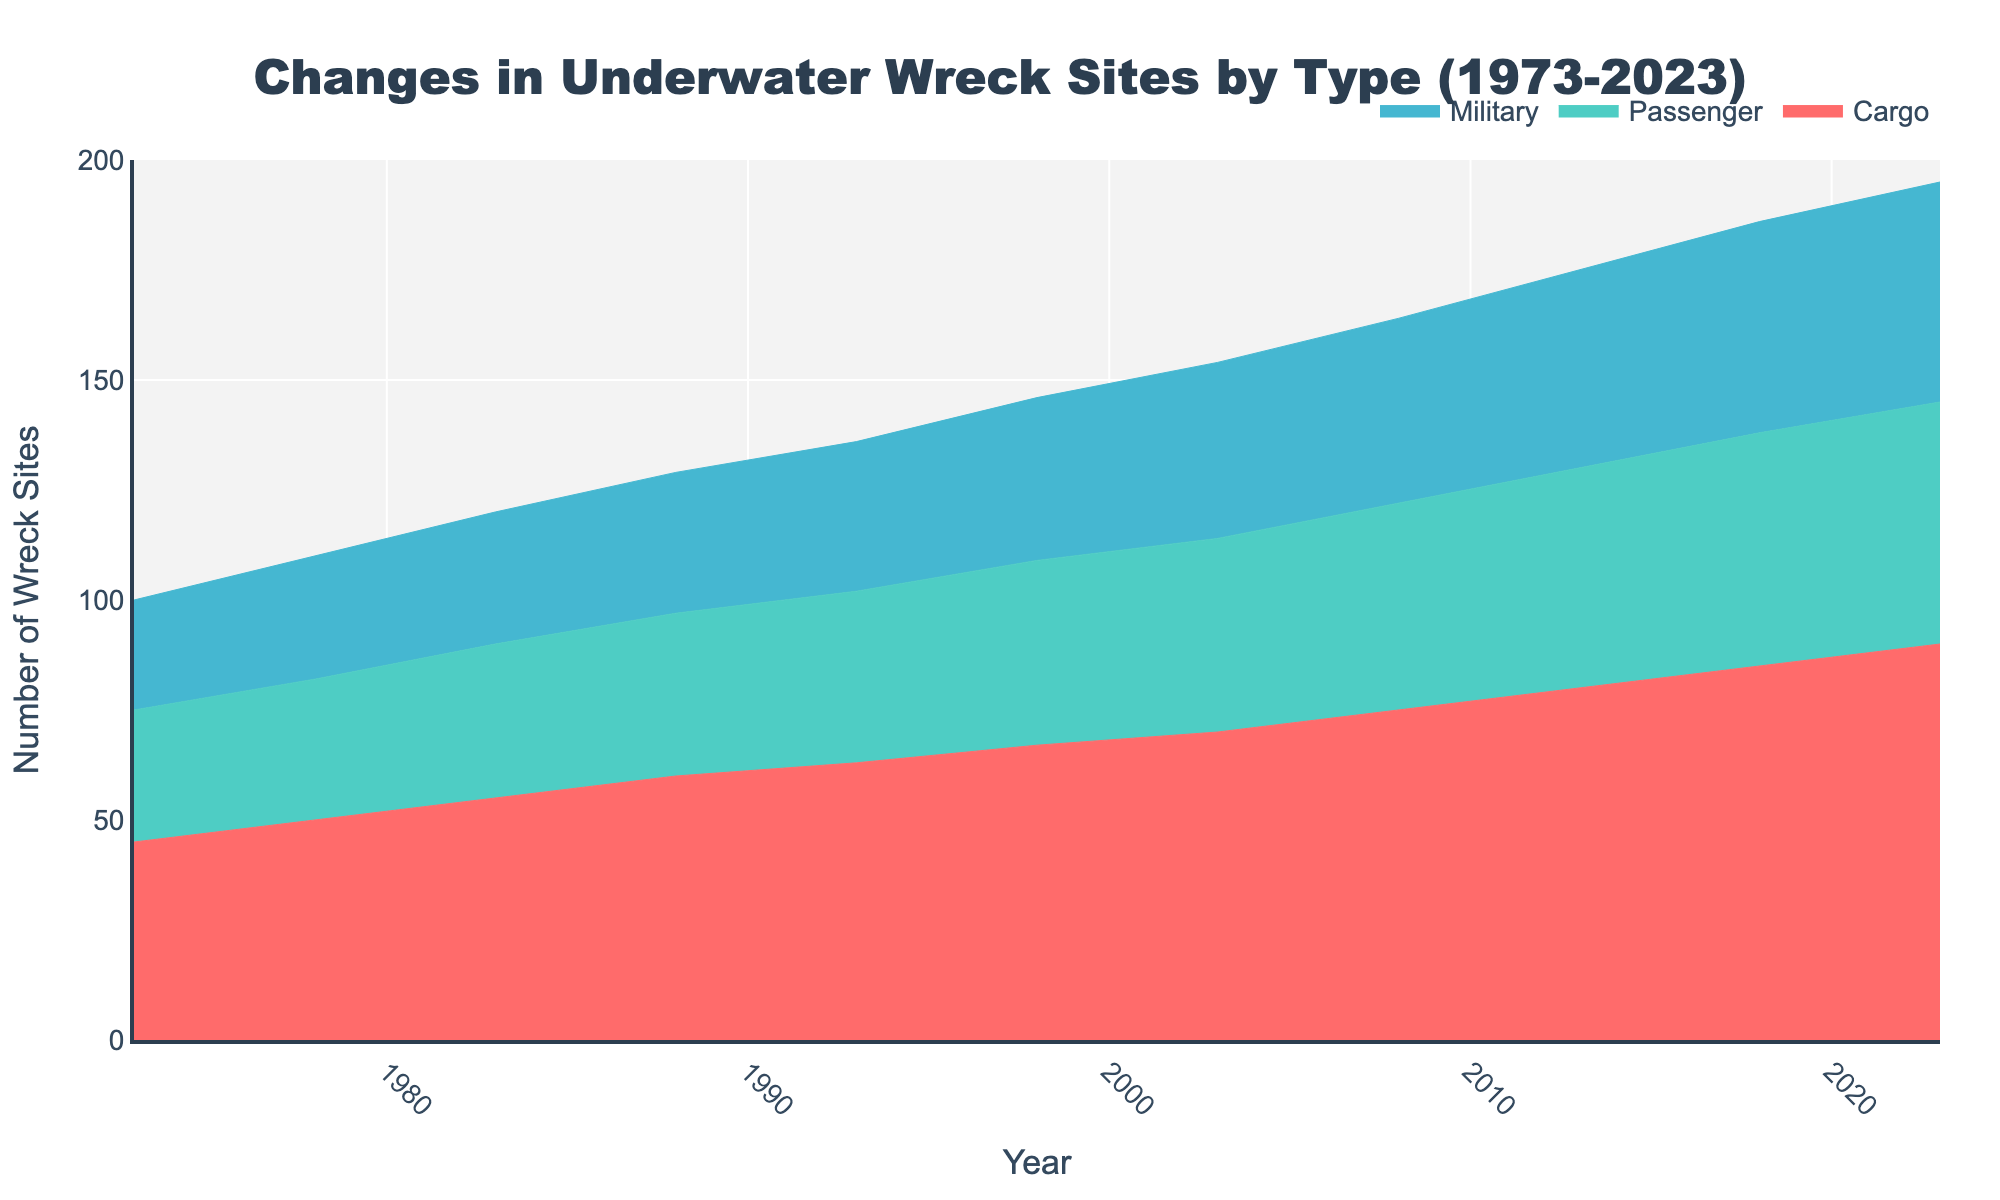What is the title of the figure? The title of the figure appears at the top and gives an overview of the data being represented. The title reads "Changes in Underwater Wreck Sites by Type (1973-2023)".
Answer: Changes in Underwater Wreck Sites by Type (1973-2023) Which type of wreck site shows the most significant increase from 1973 to 2023? To determine the type of wreck site with the most significant increase, compare the values for each type at the starting year (1973) and the ending year (2023). Cargo wreck sites increased from 45 to 90, Passenger from 30 to 55, and Military from 25 to 50. The Cargo type had the most significant increase.
Answer: Cargo How many data points are there for each type of wreck site? Count the number of distinct years along the x-axis or the number of data points shown for each type in the chart. There are 11 distinct years (data points) from 1973 to 2023 for each wreck type.
Answer: 11 By how many wreck sites did the number of Military sites increase from 1993 to 2023? Subtract the number of Military wreck sites in 1993 from the number in 2023. The values are 34 (1993) and 50 (2023). Therefore, the increase is 50 - 34 = 16.
Answer: 16 What is the sum of all wreck sites for the year 2023? Add the values of Cargo, Passenger, and Military wreck sites for the year 2023. The values are 90, 55, and 50 respectively. So, the total sum is 90 + 55 + 50 = 195.
Answer: 195 Which year saw the largest number of Passenger wreck sites, and what was that number? Examine the data points corresponding to Passenger wreck sites across the years to find the maximum value. The highest value for Passenger wreck sites is 55, which occurs in 2023.
Answer: 2023, 55 Compare the number of Cargo wreck sites in 1983 to Military wreck sites in 2003. Which is greater? Look at the data points for Cargo in 1983 (55) and Military in 2003 (40). Compare these values. Cargo wreck sites in 1983 are greater than Military wreck sites in 2003.
Answer: Cargo in 1983 Which type of wreck site had the least growth over the last 50 years? Calculate the growth for each type by subtracting the 1973 value from the 2023 value. Cargo: 90 - 45 = 45, Passenger: 55 - 30 = 25, Military: 50 - 25 = 25. Both Passenger and Military wreck sites had the least growth of 25.
Answer: Passenger and Military Is there ever a point where the number of Passenger wreck sites is more than the number of Cargo wreck sites? Compare the data points for Passenger and Cargo wreck sites across all years. Each year's value for Cargo is higher than Passenger throughout the entire period from 1973 to 2023.
Answer: No 